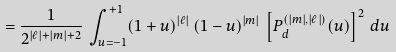<formula> <loc_0><loc_0><loc_500><loc_500>= \frac { 1 } { 2 ^ { | \ell | + | m | + 2 } } \, \int _ { u = - 1 } ^ { + 1 } ( 1 + u ) ^ { | \ell | } \, ( 1 - u ) ^ { | m | } \, \left [ P ^ { ( | m | , | \ell | ) } _ { d } ( u ) \right ] ^ { 2 } \, d u</formula> 